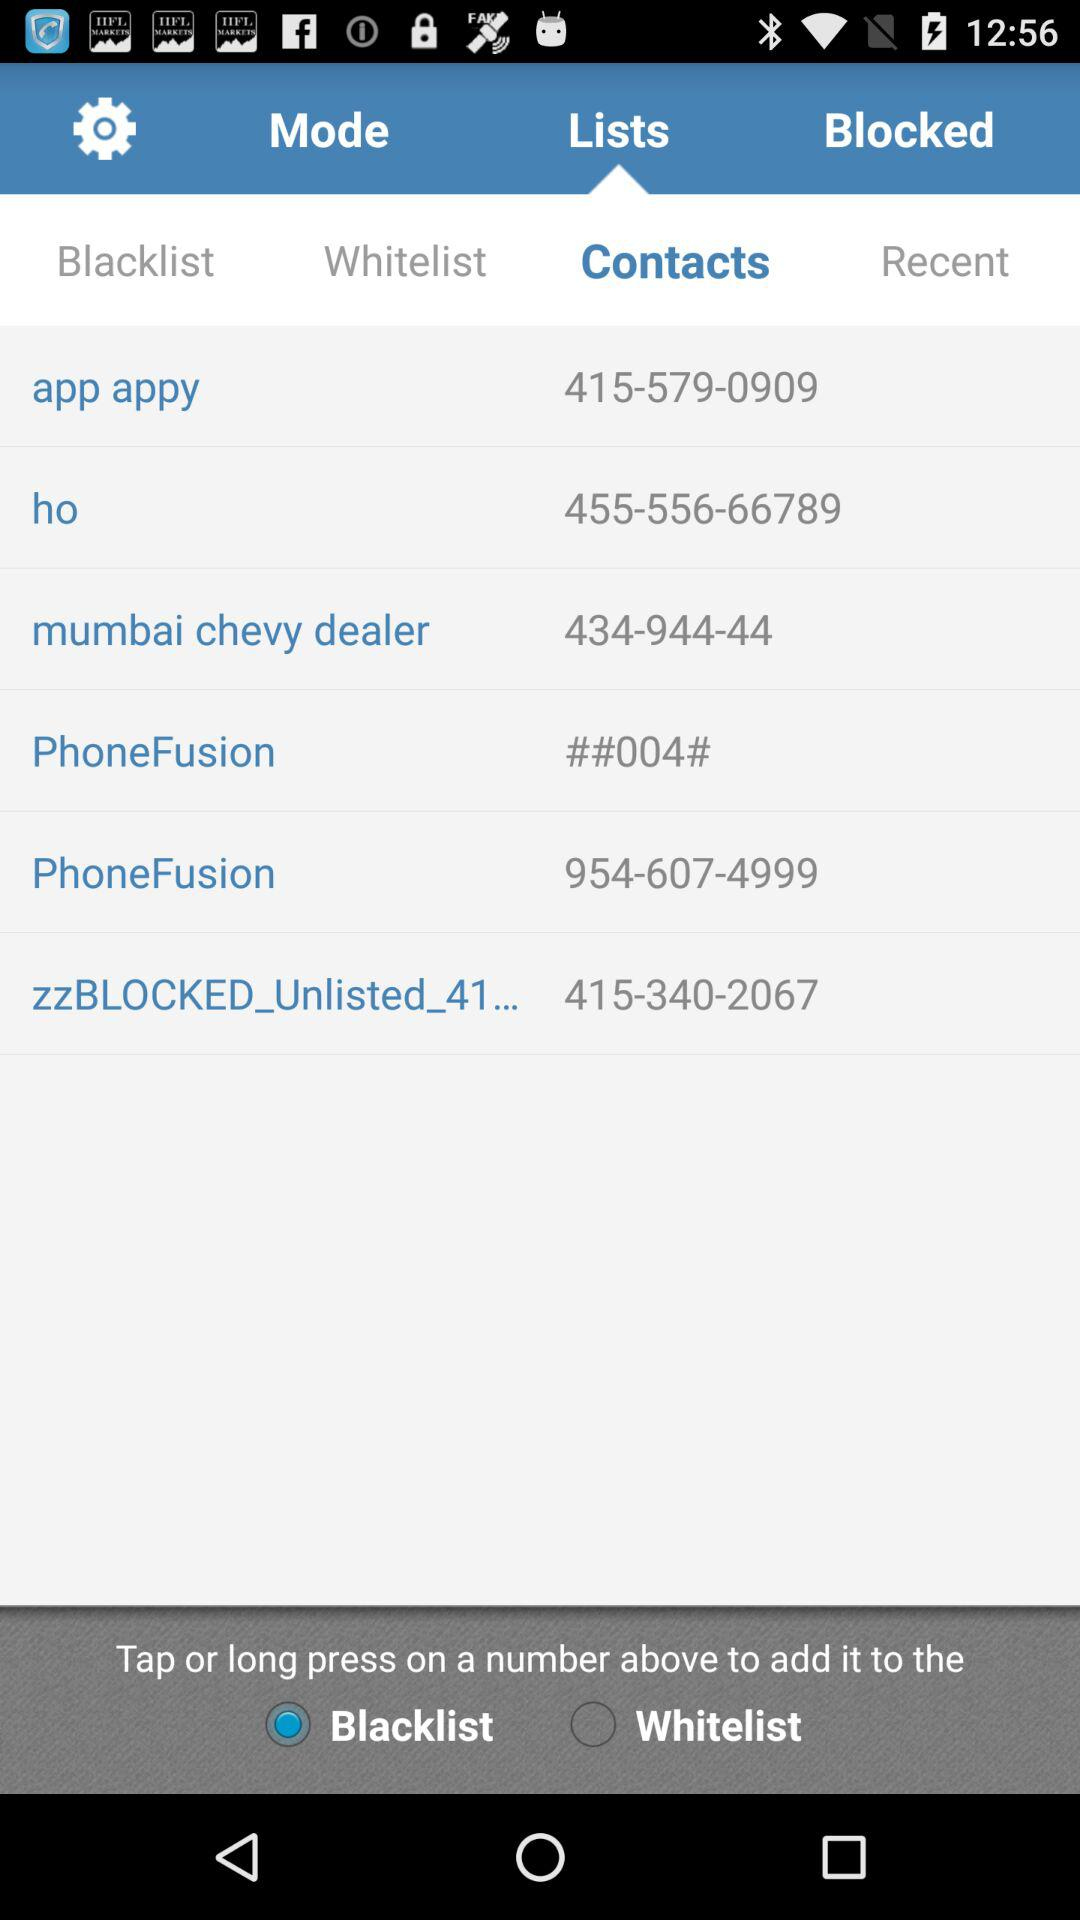What is the app appy contact number? The contact number is 415-579-0909. 